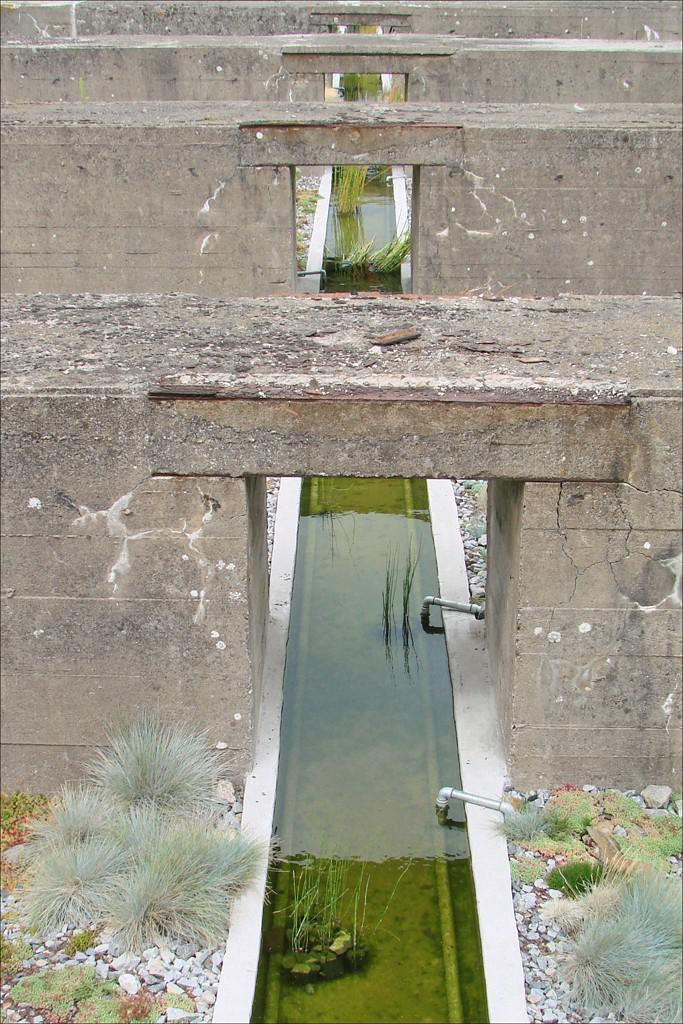What is the main feature in the image? There is a small water harvest pit in the image. What is above the water harvest pit? There are brown color brick bridges above the water harvest pit. What can be seen at the front bottom side of the image? There are white pebbles and grass in the front bottom side of the image. What type of basketball game is being played in the image? There is no basketball game present in the image. Can you tell me the name of the daughter in the image? There is no daughter present in the image. 